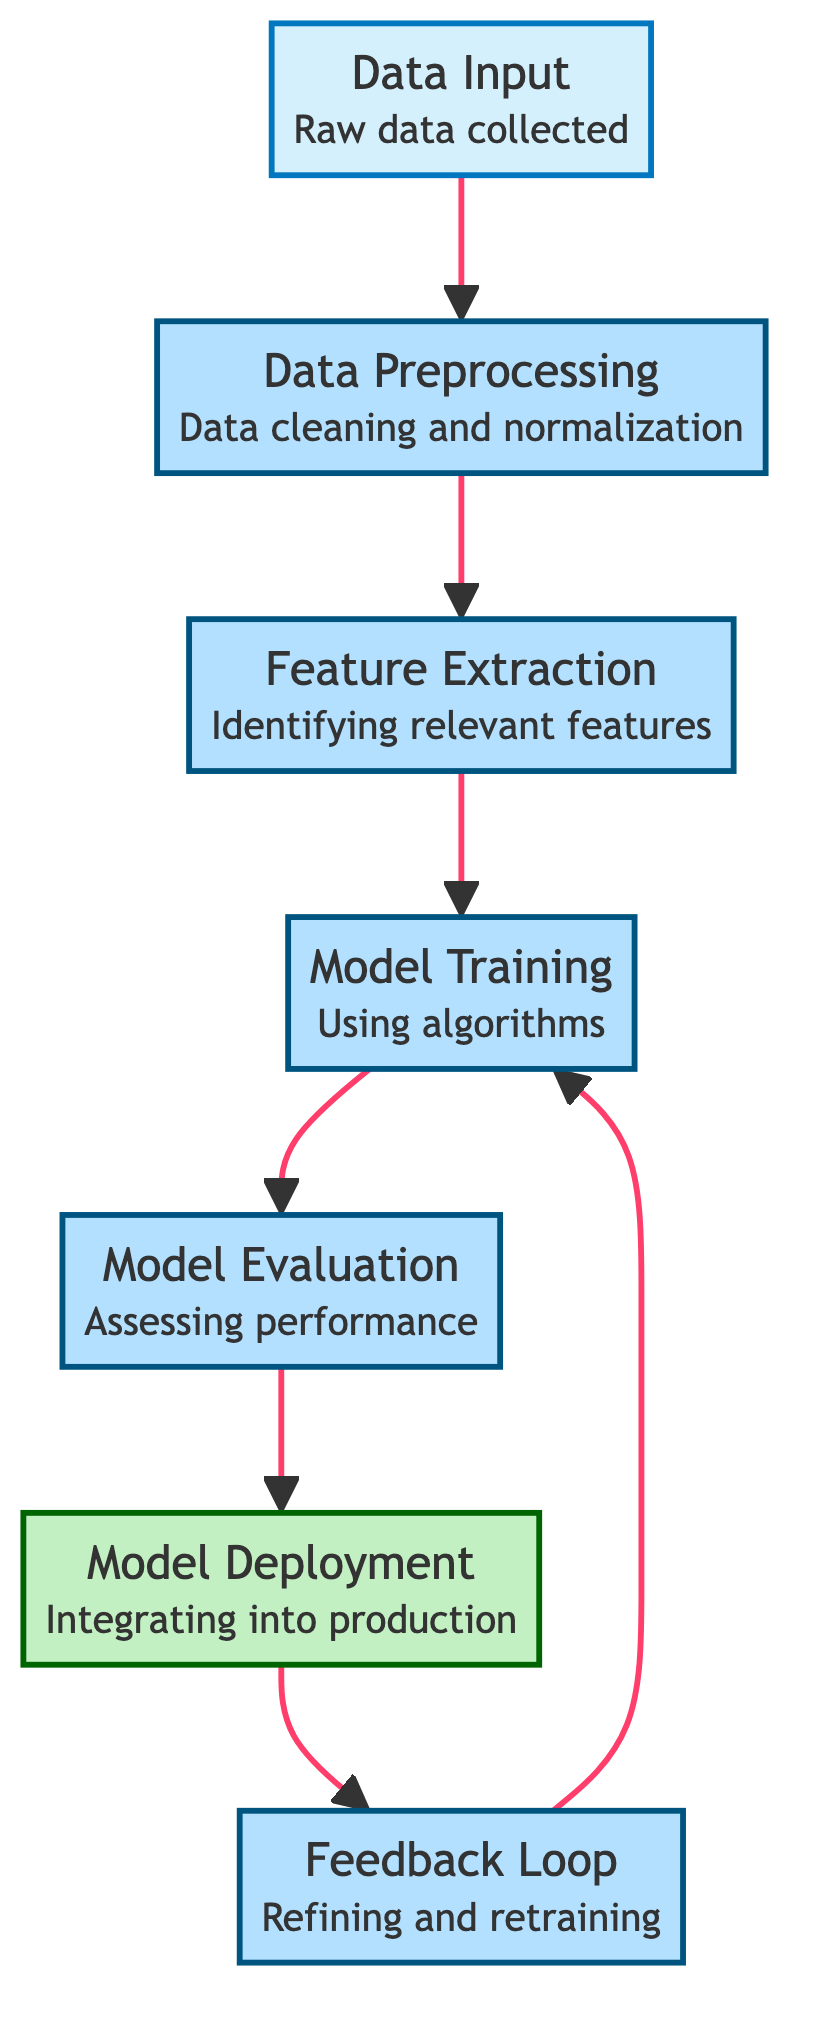What is the first stage in the computational model architecture? The first stage according to the diagram is "Data Input," which signifies the collection of raw data.
Answer: Data Input How many processing stages are there in the diagram? There are five processing stages that involve various operations from preprocessing to model training.
Answer: 5 Which node follows the "Feature Extraction" node? According to the edges connecting the nodes, "Model Training" directly follows "Feature Extraction" in the flow.
Answer: Model Training What is the last step before the "Feedback Loop"? The last step before entering the "Feedback Loop" is "Deployment," which indicates the integration of the model.
Answer: Deployment How many edges are in the diagram? The diagram contains six edges, representing the flow of data between the stages.
Answer: 6 What is the purpose of the "Feedback Loop"? The purpose of the "Feedback Loop" is to use performance data to refine and retrain the model, ensuring continuous improvement.
Answer: Refinement and retraining Which two nodes are directly connected to the "Model Evaluation" node? The two nodes directly connected to "Model Evaluation" are "Model Training," which precedes it, and "Deployment," which follows it.
Answer: Model Training and Deployment What type of data is handled in the "Data Input" stage? The "Data Input" stage handles raw data collected from sources such as sensors, databases, or APIs, indicating the origin of the data.
Answer: Raw data Which two nodes create a cyclical relationship in the diagram? The relationship between "Feedback Loop" and "Model Training" forms a cycle where feedback is used for refining the model, allowing retraining.
Answer: Feedback Loop and Model Training 